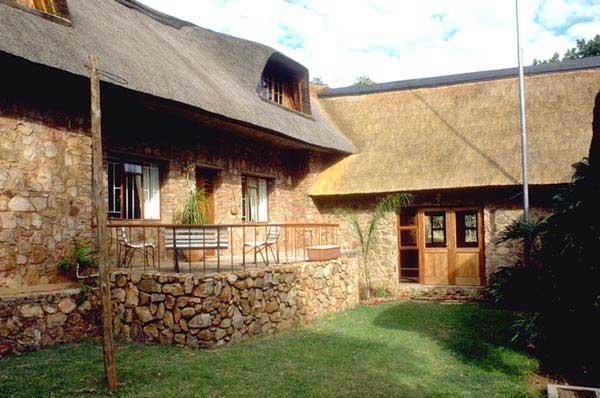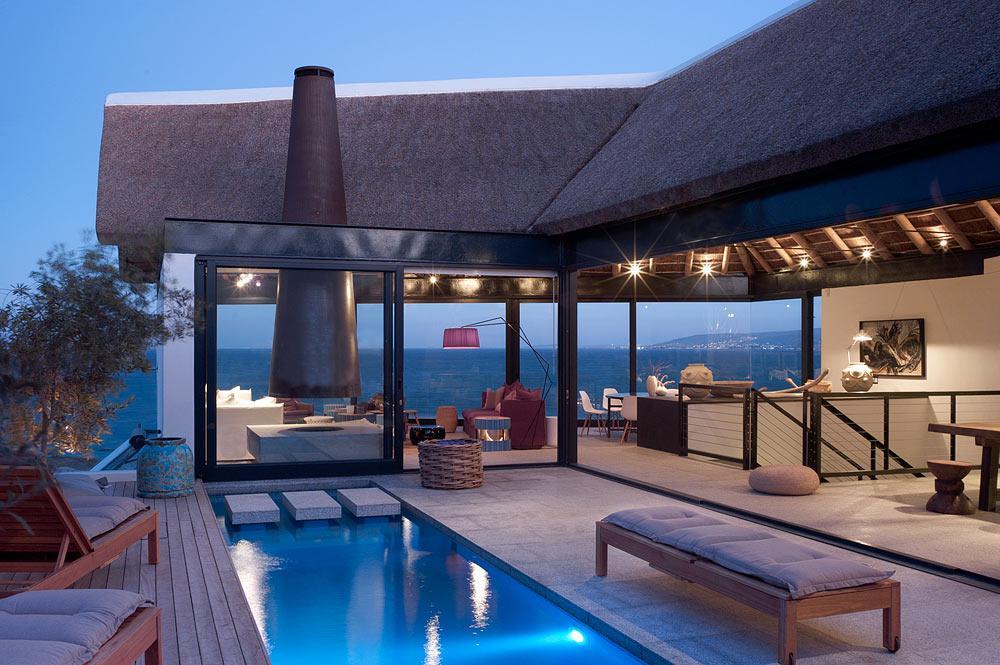The first image is the image on the left, the second image is the image on the right. For the images shown, is this caption "One of the houses is surrounded by a green lawn; it's not merely a small green field." true? Answer yes or no. Yes. The first image is the image on the left, the second image is the image on the right. Considering the images on both sides, is "The right image shows an exterior with a bench to the right of a narrow rectangular pool, and behind the pool large glass doors with a chimney above them in front of a dark roof." valid? Answer yes or no. Yes. 